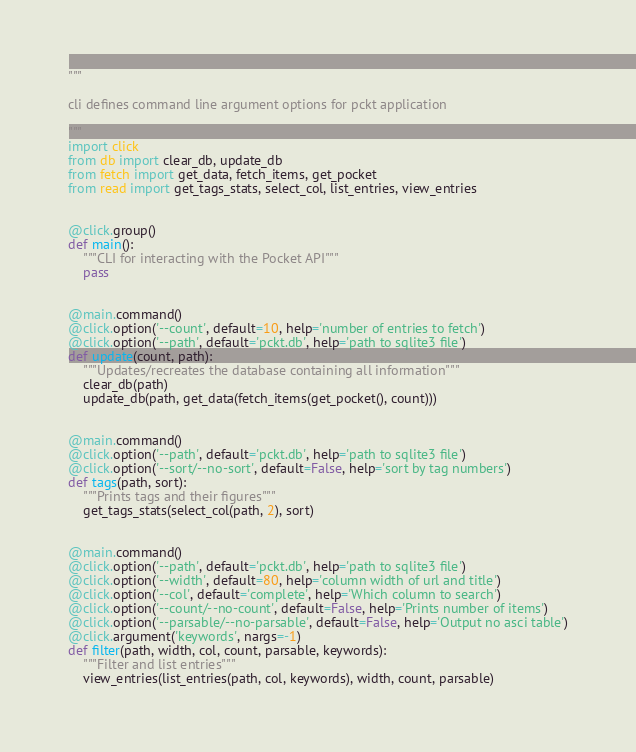Convert code to text. <code><loc_0><loc_0><loc_500><loc_500><_Python_>"""

cli defines command line argument options for pckt application

"""
import click
from db import clear_db, update_db
from fetch import get_data, fetch_items, get_pocket
from read import get_tags_stats, select_col, list_entries, view_entries


@click.group()
def main():
    """CLI for interacting with the Pocket API"""
    pass


@main.command()
@click.option('--count', default=10, help='number of entries to fetch')
@click.option('--path', default='pckt.db', help='path to sqlite3 file')
def update(count, path):
    """Updates/recreates the database containing all information"""
    clear_db(path)
    update_db(path, get_data(fetch_items(get_pocket(), count)))


@main.command()
@click.option('--path', default='pckt.db', help='path to sqlite3 file')
@click.option('--sort/--no-sort', default=False, help='sort by tag numbers')
def tags(path, sort):
    """Prints tags and their figures"""
    get_tags_stats(select_col(path, 2), sort)


@main.command()
@click.option('--path', default='pckt.db', help='path to sqlite3 file')
@click.option('--width', default=80, help='column width of url and title')
@click.option('--col', default='complete', help='Which column to search')
@click.option('--count/--no-count', default=False, help='Prints number of items')
@click.option('--parsable/--no-parsable', default=False, help='Output no asci table')
@click.argument('keywords', nargs=-1)
def filter(path, width, col, count, parsable, keywords):
    """Filter and list entries"""
    view_entries(list_entries(path, col, keywords), width, count, parsable)
</code> 